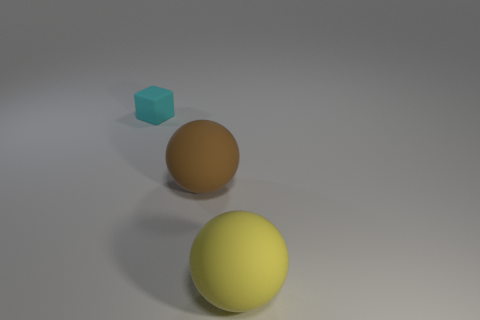What color is the block that is the same material as the large yellow object?
Provide a succinct answer. Cyan. Is there anything else that has the same size as the cyan object?
Provide a short and direct response. No. How many objects are either large balls right of the large brown object or rubber things that are left of the large brown rubber sphere?
Offer a very short reply. 2. There is a rubber sphere that is in front of the brown ball; does it have the same size as the matte sphere left of the yellow ball?
Provide a succinct answer. Yes. There is another matte thing that is the same shape as the big brown thing; what is its color?
Your response must be concise. Yellow. Are there any other things that have the same shape as the yellow object?
Make the answer very short. Yes. Are there more cyan objects right of the yellow ball than blocks left of the tiny thing?
Offer a terse response. No. There is a rubber thing that is on the left side of the big ball that is left of the ball in front of the brown object; how big is it?
Your answer should be very brief. Small. Does the yellow matte object have the same shape as the brown object?
Keep it short and to the point. Yes. How many other objects are the same material as the cyan thing?
Your answer should be compact. 2. 